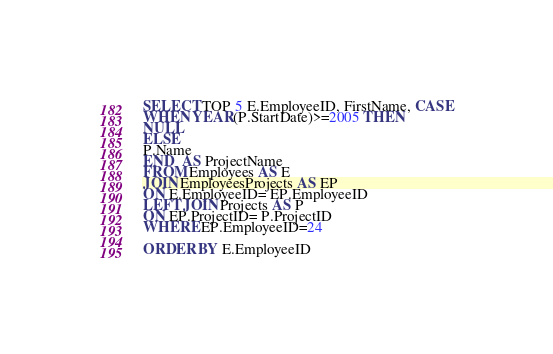Convert code to text. <code><loc_0><loc_0><loc_500><loc_500><_SQL_>SELECT TOP 5 E.EmployeeID, FirstName, CASE
WHEN YEAR(P.StartDate)>=2005 THEN
NULL
ELSE
P.Name
END  AS ProjectName 
FROM Employees AS E
JOIN EmployeesProjects AS EP
ON E.EmployeeID= EP.EmployeeID
LEFT JOIN Projects AS P
ON EP.ProjectID= P.ProjectID
WHERE EP.EmployeeID=24

ORDER BY E.EmployeeID</code> 